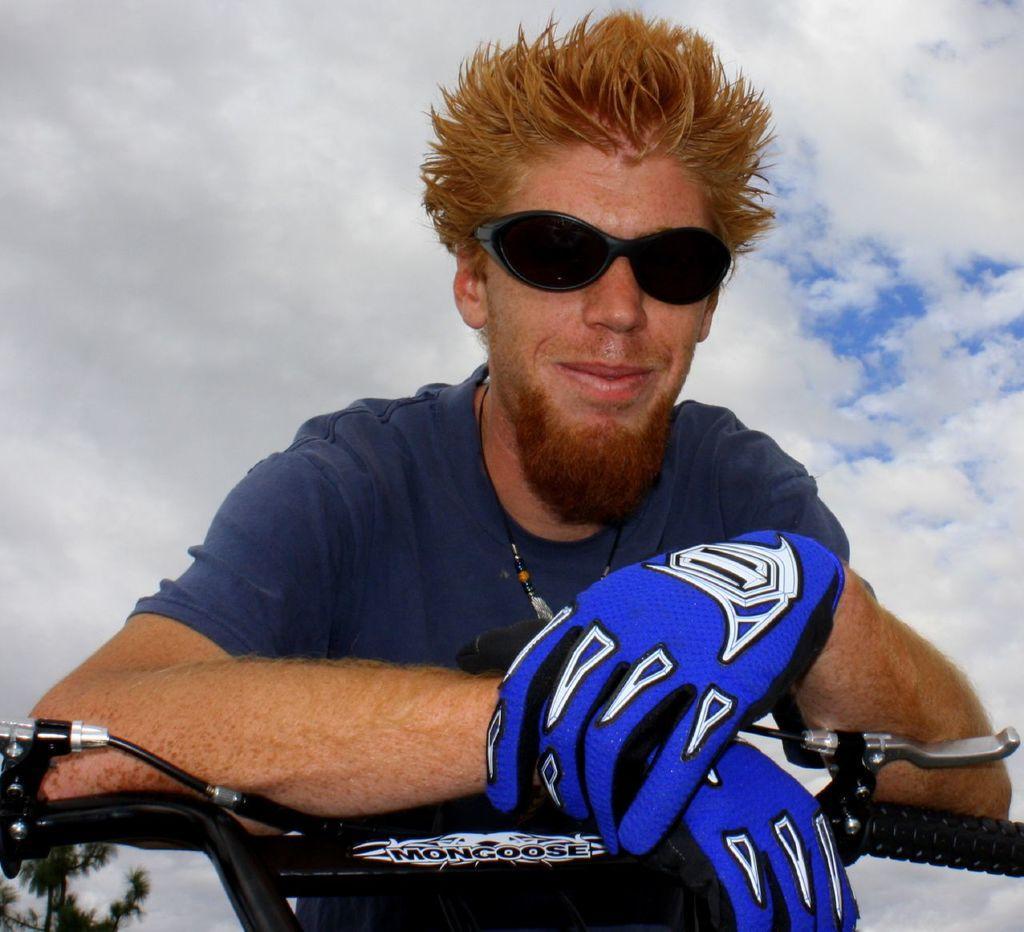Describe this image in one or two sentences. This image is taken in outdoors. In this image there is a man placing his hands on a bike wearing a gloves to his hand. At the background there is a sky with clouds and trees. 